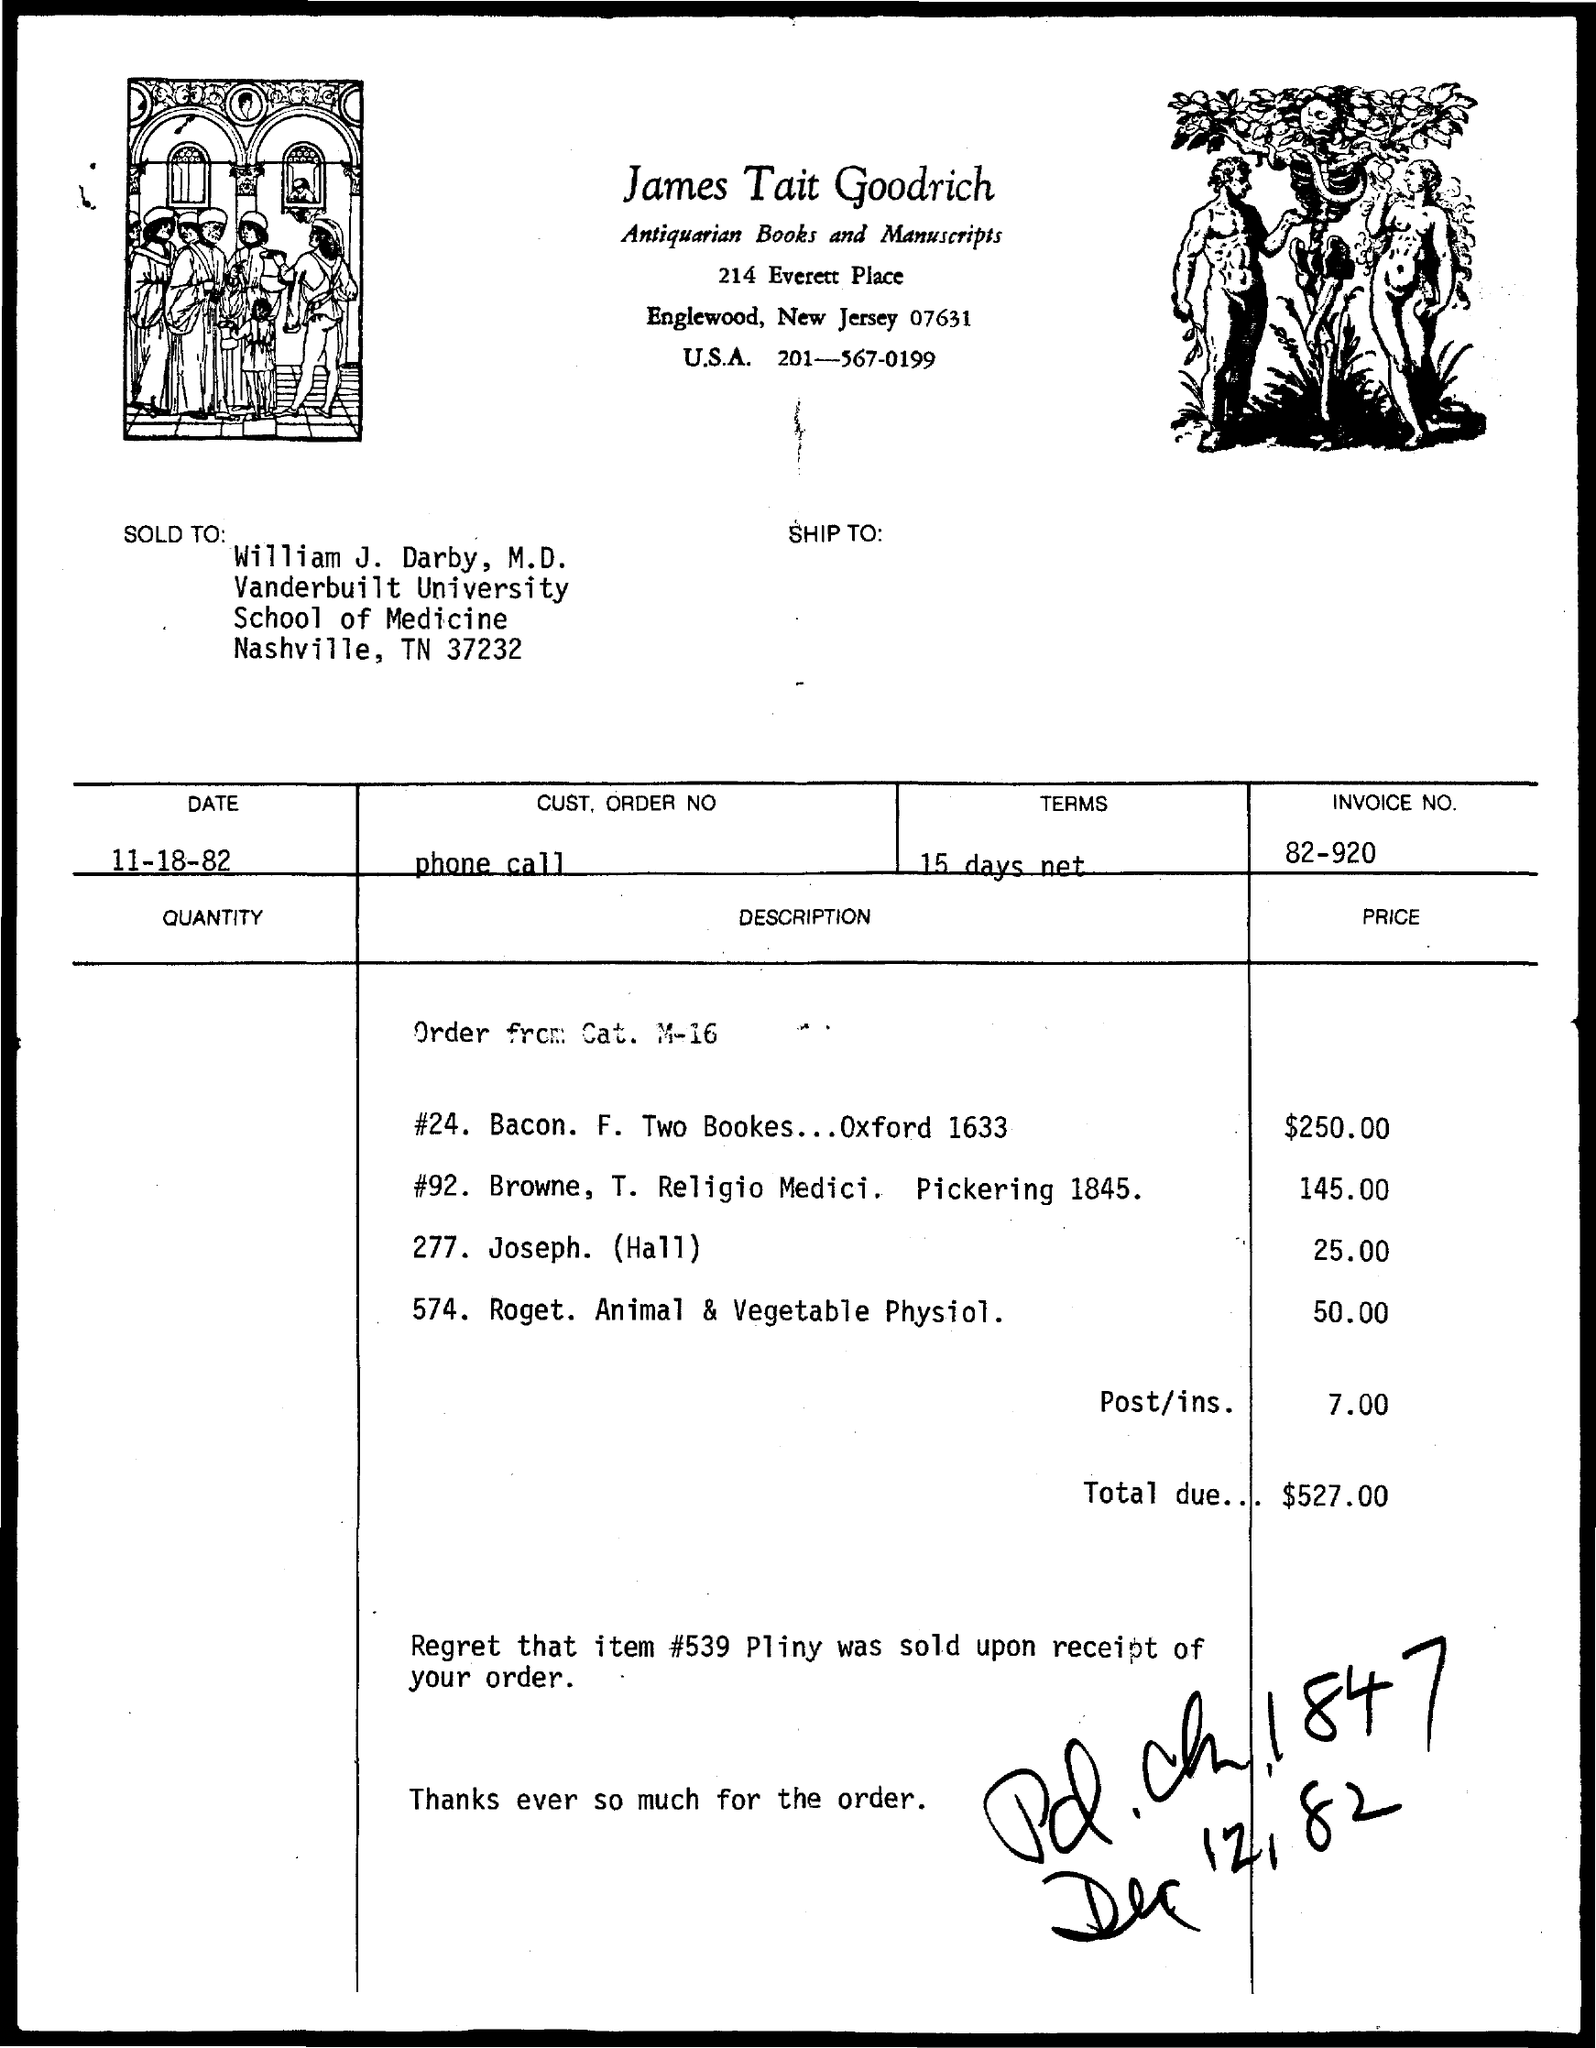Highlight a few significant elements in this photo. The INVOICE number is 82-920. 